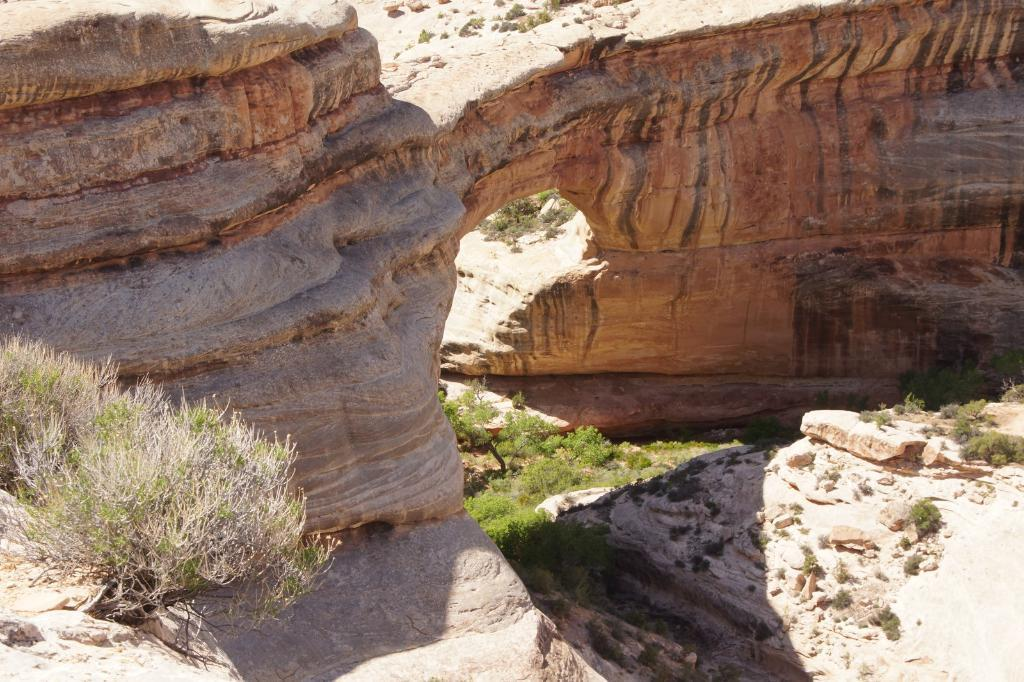What type of living organisms can be seen in the image? Plants can be seen in the image. What other objects are present in the image besides plants? There are stones in the image. Can you describe the background of the image? There is a rock visible in the background of the image. What type of interest is being earned by the plants in the image? There is no indication in the image that the plants are earning any interest. Can you tell me how many apples are on the plants in the image? There are no apples present in the image; it only features plants and stones. 